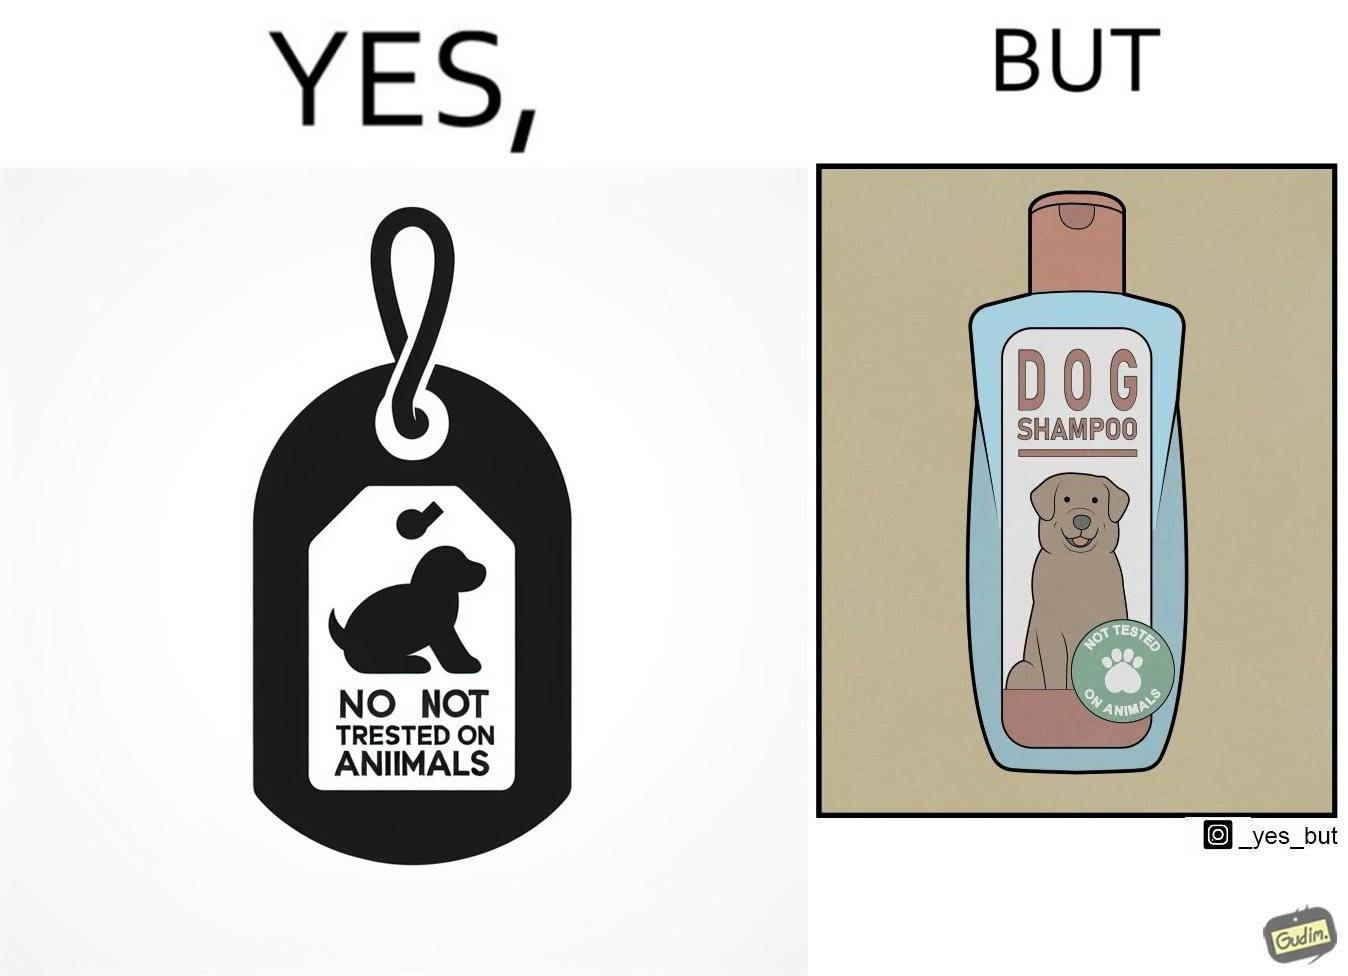Does this image contain satire or humor? Yes, this image is satirical. 